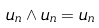Convert formula to latex. <formula><loc_0><loc_0><loc_500><loc_500>u _ { n } \wedge u _ { n } = u _ { n }</formula> 